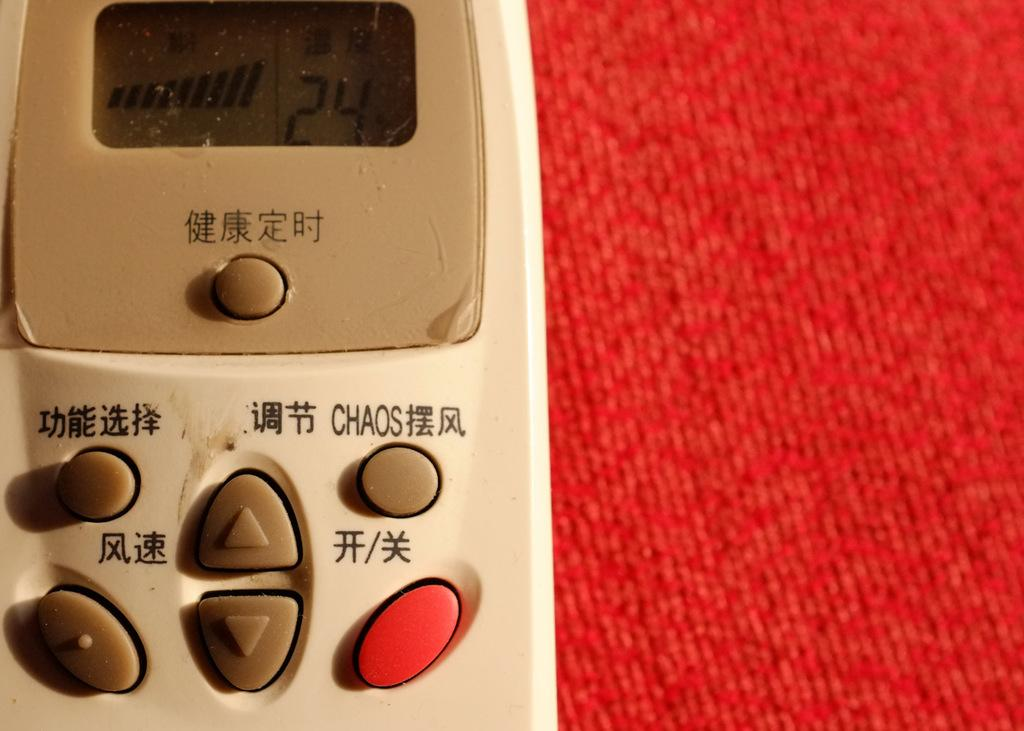<image>
Offer a succinct explanation of the picture presented. The white and brown device with japanese characters with a button that says chaos in the top right. 